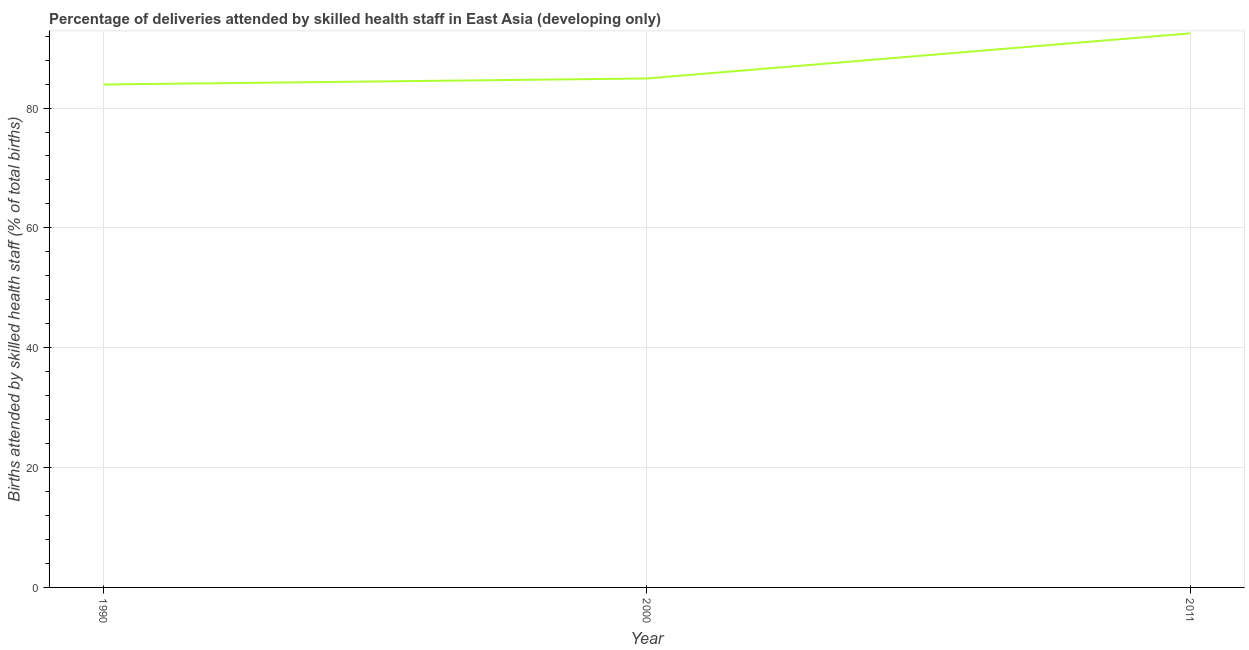What is the number of births attended by skilled health staff in 1990?
Your response must be concise. 83.93. Across all years, what is the maximum number of births attended by skilled health staff?
Your answer should be very brief. 92.46. Across all years, what is the minimum number of births attended by skilled health staff?
Provide a succinct answer. 83.93. In which year was the number of births attended by skilled health staff maximum?
Make the answer very short. 2011. What is the sum of the number of births attended by skilled health staff?
Ensure brevity in your answer.  261.32. What is the difference between the number of births attended by skilled health staff in 2000 and 2011?
Offer a terse response. -7.53. What is the average number of births attended by skilled health staff per year?
Provide a succinct answer. 87.11. What is the median number of births attended by skilled health staff?
Offer a terse response. 84.93. Do a majority of the years between 2011 and 2000 (inclusive) have number of births attended by skilled health staff greater than 80 %?
Provide a short and direct response. No. What is the ratio of the number of births attended by skilled health staff in 1990 to that in 2011?
Keep it short and to the point. 0.91. Is the number of births attended by skilled health staff in 2000 less than that in 2011?
Offer a terse response. Yes. What is the difference between the highest and the second highest number of births attended by skilled health staff?
Give a very brief answer. 7.53. What is the difference between the highest and the lowest number of births attended by skilled health staff?
Provide a succinct answer. 8.53. How many years are there in the graph?
Your response must be concise. 3. Are the values on the major ticks of Y-axis written in scientific E-notation?
Your answer should be compact. No. What is the title of the graph?
Your response must be concise. Percentage of deliveries attended by skilled health staff in East Asia (developing only). What is the label or title of the Y-axis?
Keep it short and to the point. Births attended by skilled health staff (% of total births). What is the Births attended by skilled health staff (% of total births) of 1990?
Your answer should be compact. 83.93. What is the Births attended by skilled health staff (% of total births) of 2000?
Give a very brief answer. 84.93. What is the Births attended by skilled health staff (% of total births) in 2011?
Make the answer very short. 92.46. What is the difference between the Births attended by skilled health staff (% of total births) in 1990 and 2000?
Offer a terse response. -1. What is the difference between the Births attended by skilled health staff (% of total births) in 1990 and 2011?
Give a very brief answer. -8.53. What is the difference between the Births attended by skilled health staff (% of total births) in 2000 and 2011?
Your response must be concise. -7.53. What is the ratio of the Births attended by skilled health staff (% of total births) in 1990 to that in 2011?
Your answer should be very brief. 0.91. What is the ratio of the Births attended by skilled health staff (% of total births) in 2000 to that in 2011?
Make the answer very short. 0.92. 